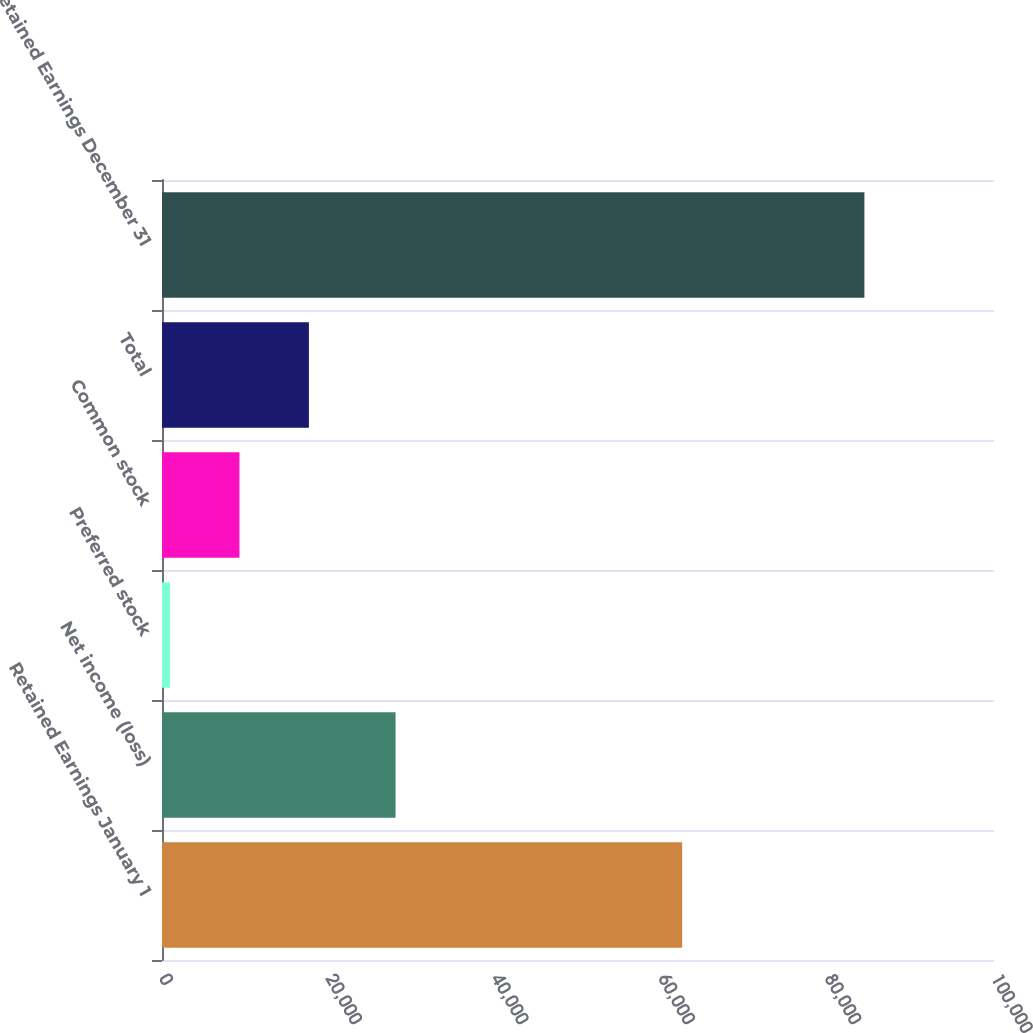Convert chart. <chart><loc_0><loc_0><loc_500><loc_500><bar_chart><fcel>Retained Earnings January 1<fcel>Net income (loss)<fcel>Preferred stock<fcel>Common stock<fcel>Total<fcel>Retained Earnings December 31<nl><fcel>62517<fcel>28072<fcel>965<fcel>9310.9<fcel>17656.8<fcel>84424<nl></chart> 